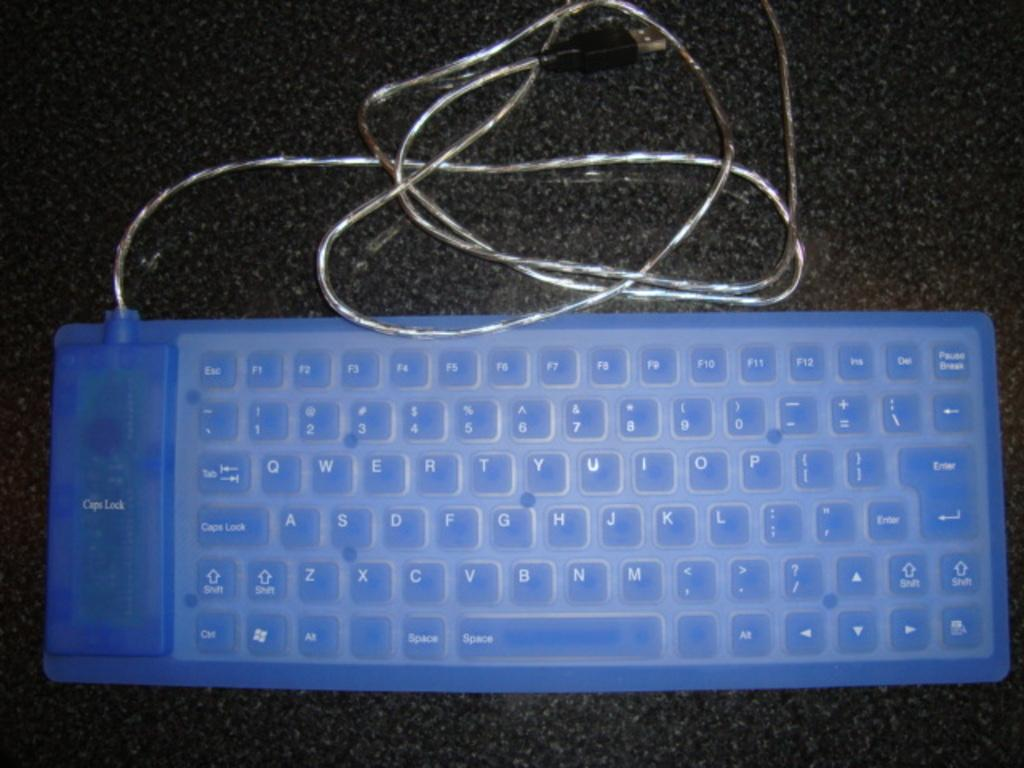<image>
Describe the image concisely. a keyboard with a blue cover reading Caps Lock 